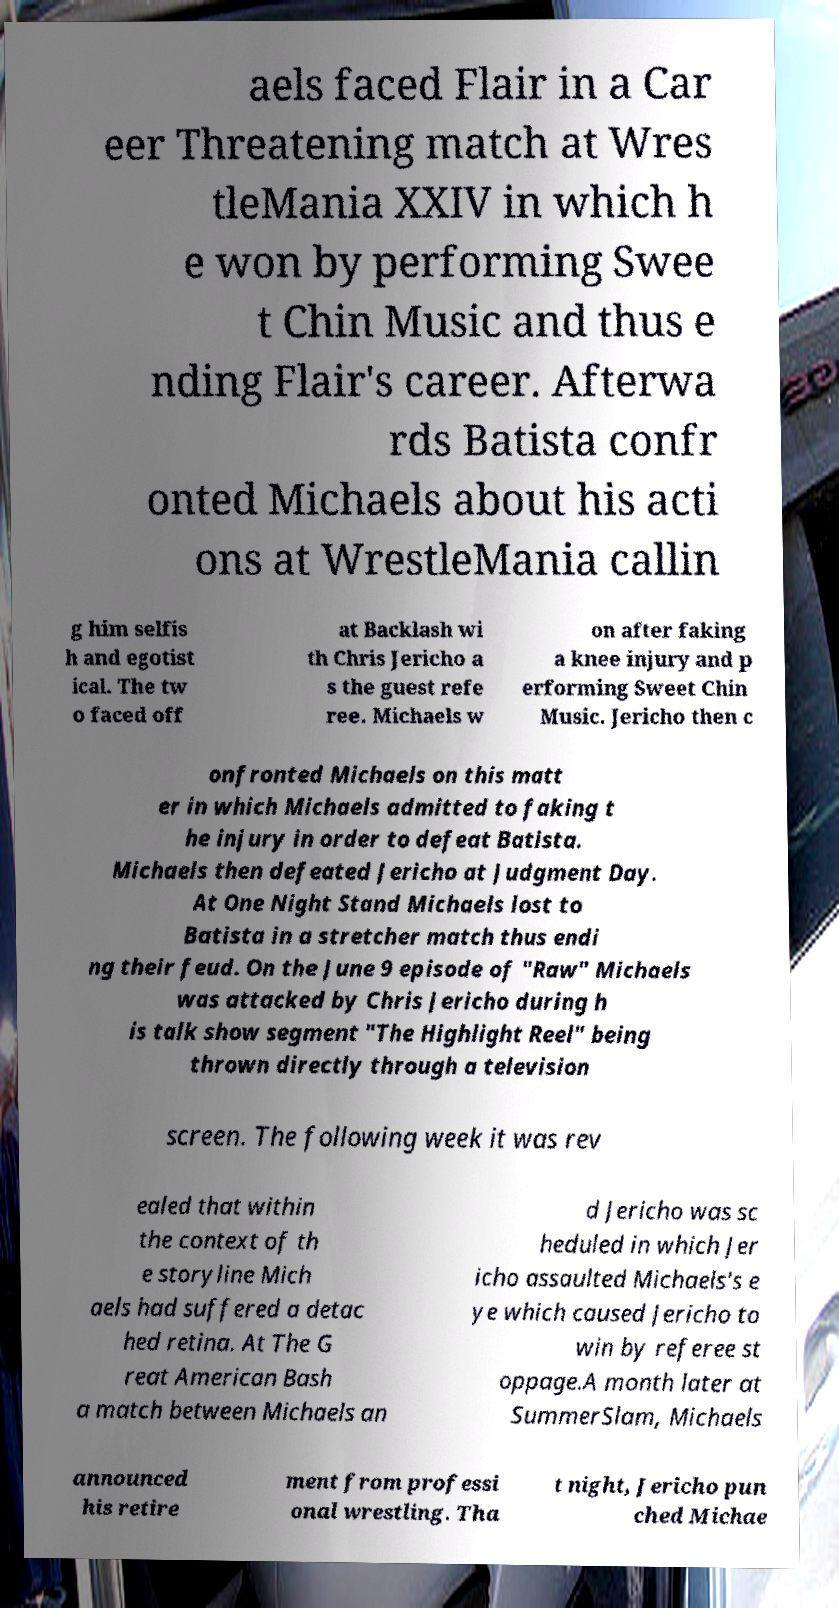I need the written content from this picture converted into text. Can you do that? aels faced Flair in a Car eer Threatening match at Wres tleMania XXIV in which h e won by performing Swee t Chin Music and thus e nding Flair's career. Afterwa rds Batista confr onted Michaels about his acti ons at WrestleMania callin g him selfis h and egotist ical. The tw o faced off at Backlash wi th Chris Jericho a s the guest refe ree. Michaels w on after faking a knee injury and p erforming Sweet Chin Music. Jericho then c onfronted Michaels on this matt er in which Michaels admitted to faking t he injury in order to defeat Batista. Michaels then defeated Jericho at Judgment Day. At One Night Stand Michaels lost to Batista in a stretcher match thus endi ng their feud. On the June 9 episode of "Raw" Michaels was attacked by Chris Jericho during h is talk show segment "The Highlight Reel" being thrown directly through a television screen. The following week it was rev ealed that within the context of th e storyline Mich aels had suffered a detac hed retina. At The G reat American Bash a match between Michaels an d Jericho was sc heduled in which Jer icho assaulted Michaels's e ye which caused Jericho to win by referee st oppage.A month later at SummerSlam, Michaels announced his retire ment from professi onal wrestling. Tha t night, Jericho pun ched Michae 